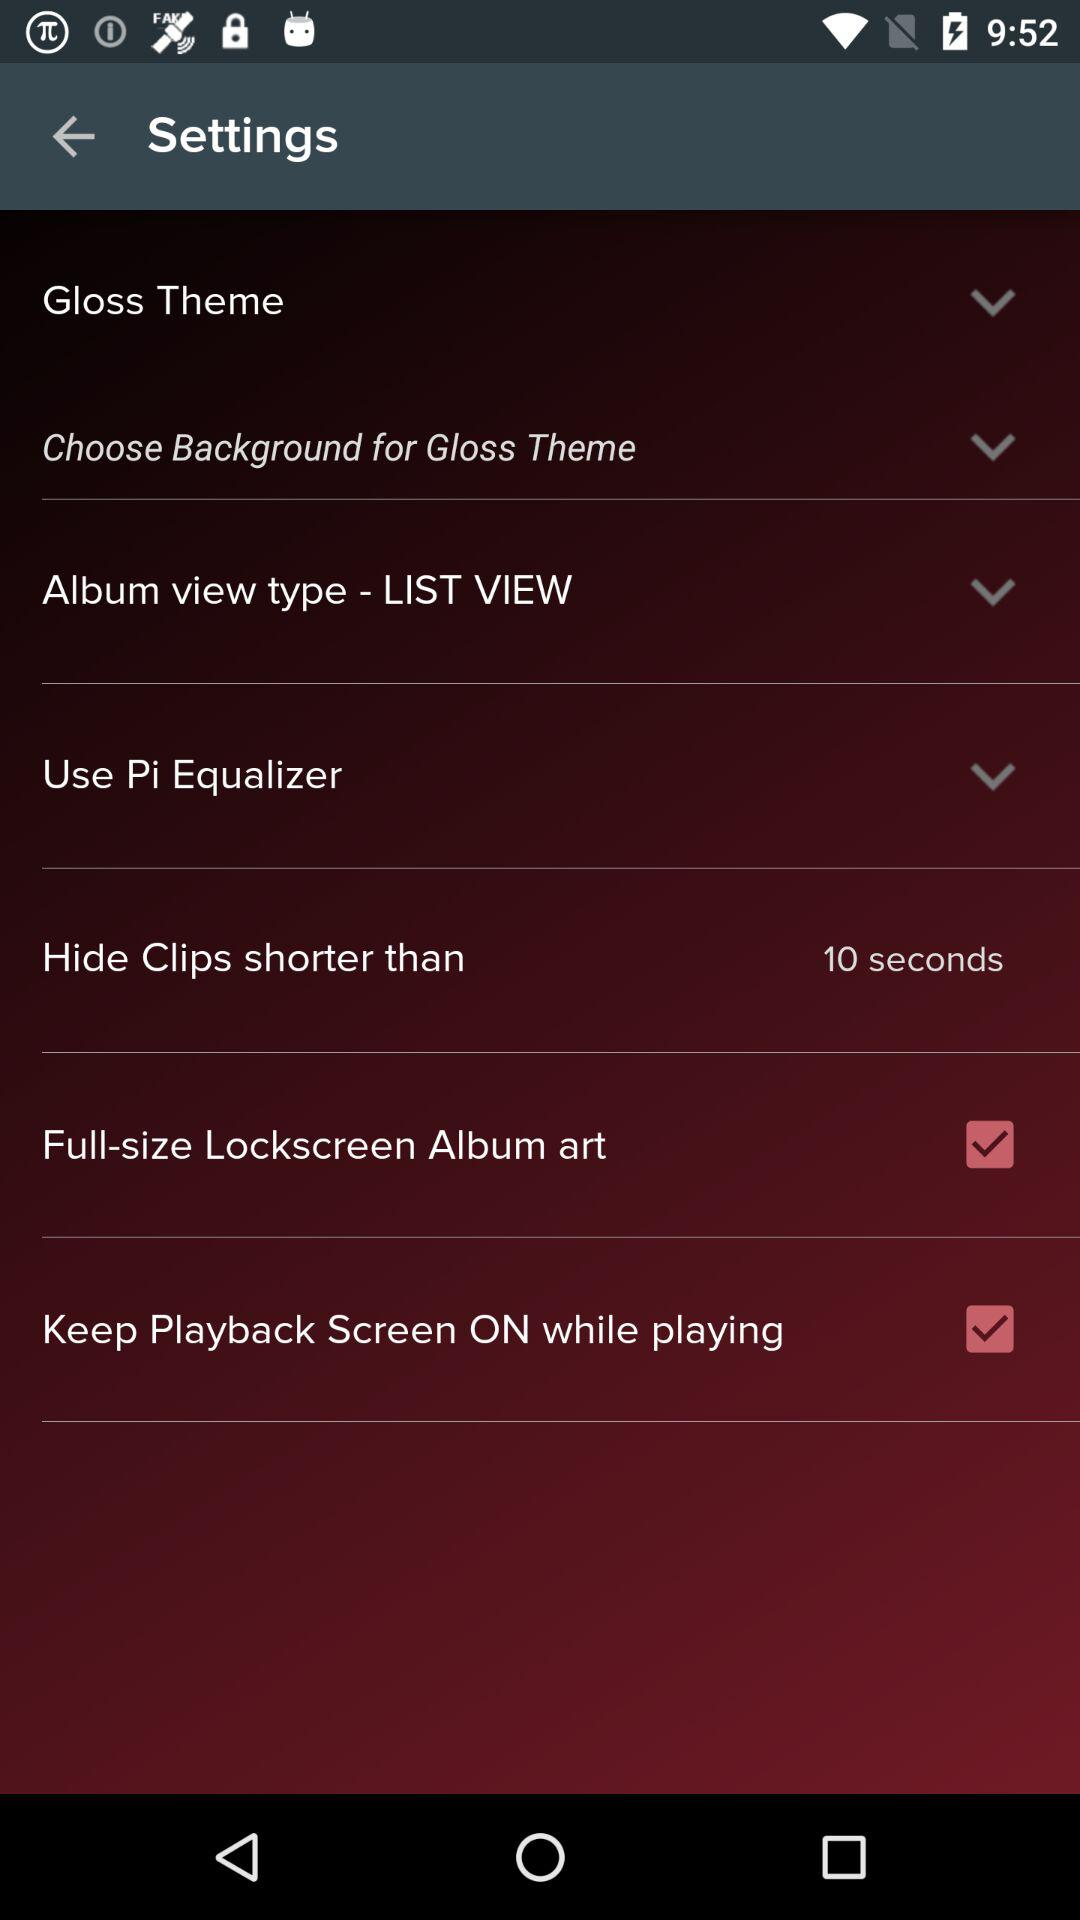What should be the length of the clip to hide? The length of the clip to hide should be shorter than 10 seconds. 